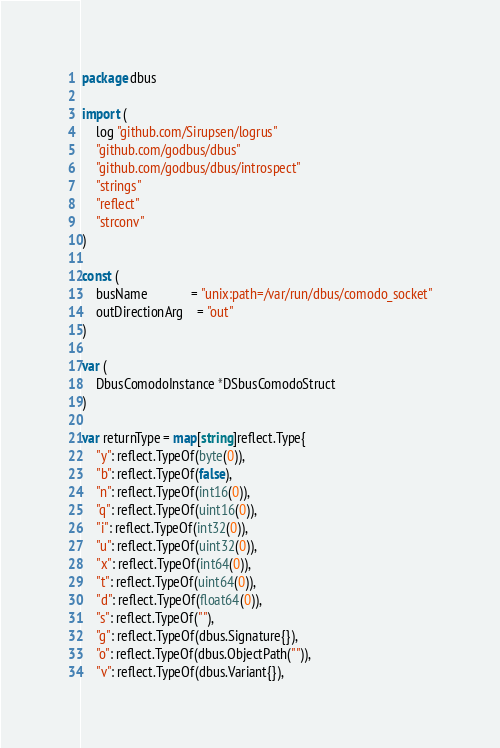<code> <loc_0><loc_0><loc_500><loc_500><_Go_>package dbus

import (
	log "github.com/Sirupsen/logrus"
	"github.com/godbus/dbus"
	"github.com/godbus/dbus/introspect"
	"strings"
	"reflect"
	"strconv"
)

const (
	busName             = "unix:path=/var/run/dbus/comodo_socket"
	outDirectionArg 	= "out"
)

var (
	DbusComodoInstance *DSbusComodoStruct
)

var returnType = map[string]reflect.Type{
	"y": reflect.TypeOf(byte(0)),
	"b": reflect.TypeOf(false),
	"n": reflect.TypeOf(int16(0)),
	"q": reflect.TypeOf(uint16(0)),
	"i": reflect.TypeOf(int32(0)),
	"u": reflect.TypeOf(uint32(0)),
	"x": reflect.TypeOf(int64(0)),
	"t": reflect.TypeOf(uint64(0)),
	"d": reflect.TypeOf(float64(0)),
	"s": reflect.TypeOf(""),
	"g": reflect.TypeOf(dbus.Signature{}),
	"o": reflect.TypeOf(dbus.ObjectPath("")),
	"v": reflect.TypeOf(dbus.Variant{}),</code> 